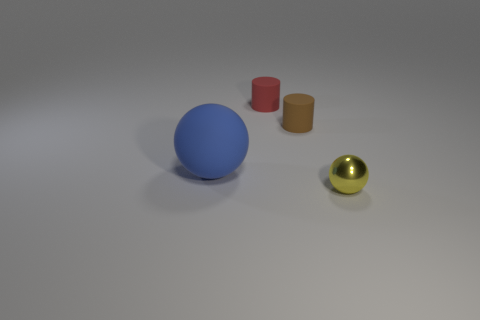What material is the tiny red object?
Offer a terse response. Rubber. What number of other red things have the same shape as the small red thing?
Offer a very short reply. 0. Is there anything else that is the same shape as the blue matte object?
Provide a short and direct response. Yes. There is a cylinder right of the small rubber thing to the left of the matte cylinder that is in front of the tiny red thing; what is its color?
Make the answer very short. Brown. What number of small things are either rubber balls or cylinders?
Ensure brevity in your answer.  2. Are there the same number of blue matte things that are in front of the tiny yellow metallic sphere and things?
Your response must be concise. No. There is a brown matte cylinder; are there any cylinders on the left side of it?
Your response must be concise. Yes. How many metal objects are either blue things or big blue cubes?
Ensure brevity in your answer.  0. There is a blue sphere; what number of tiny things are to the left of it?
Your response must be concise. 0. Is there another sphere that has the same size as the yellow metal ball?
Give a very brief answer. No. 